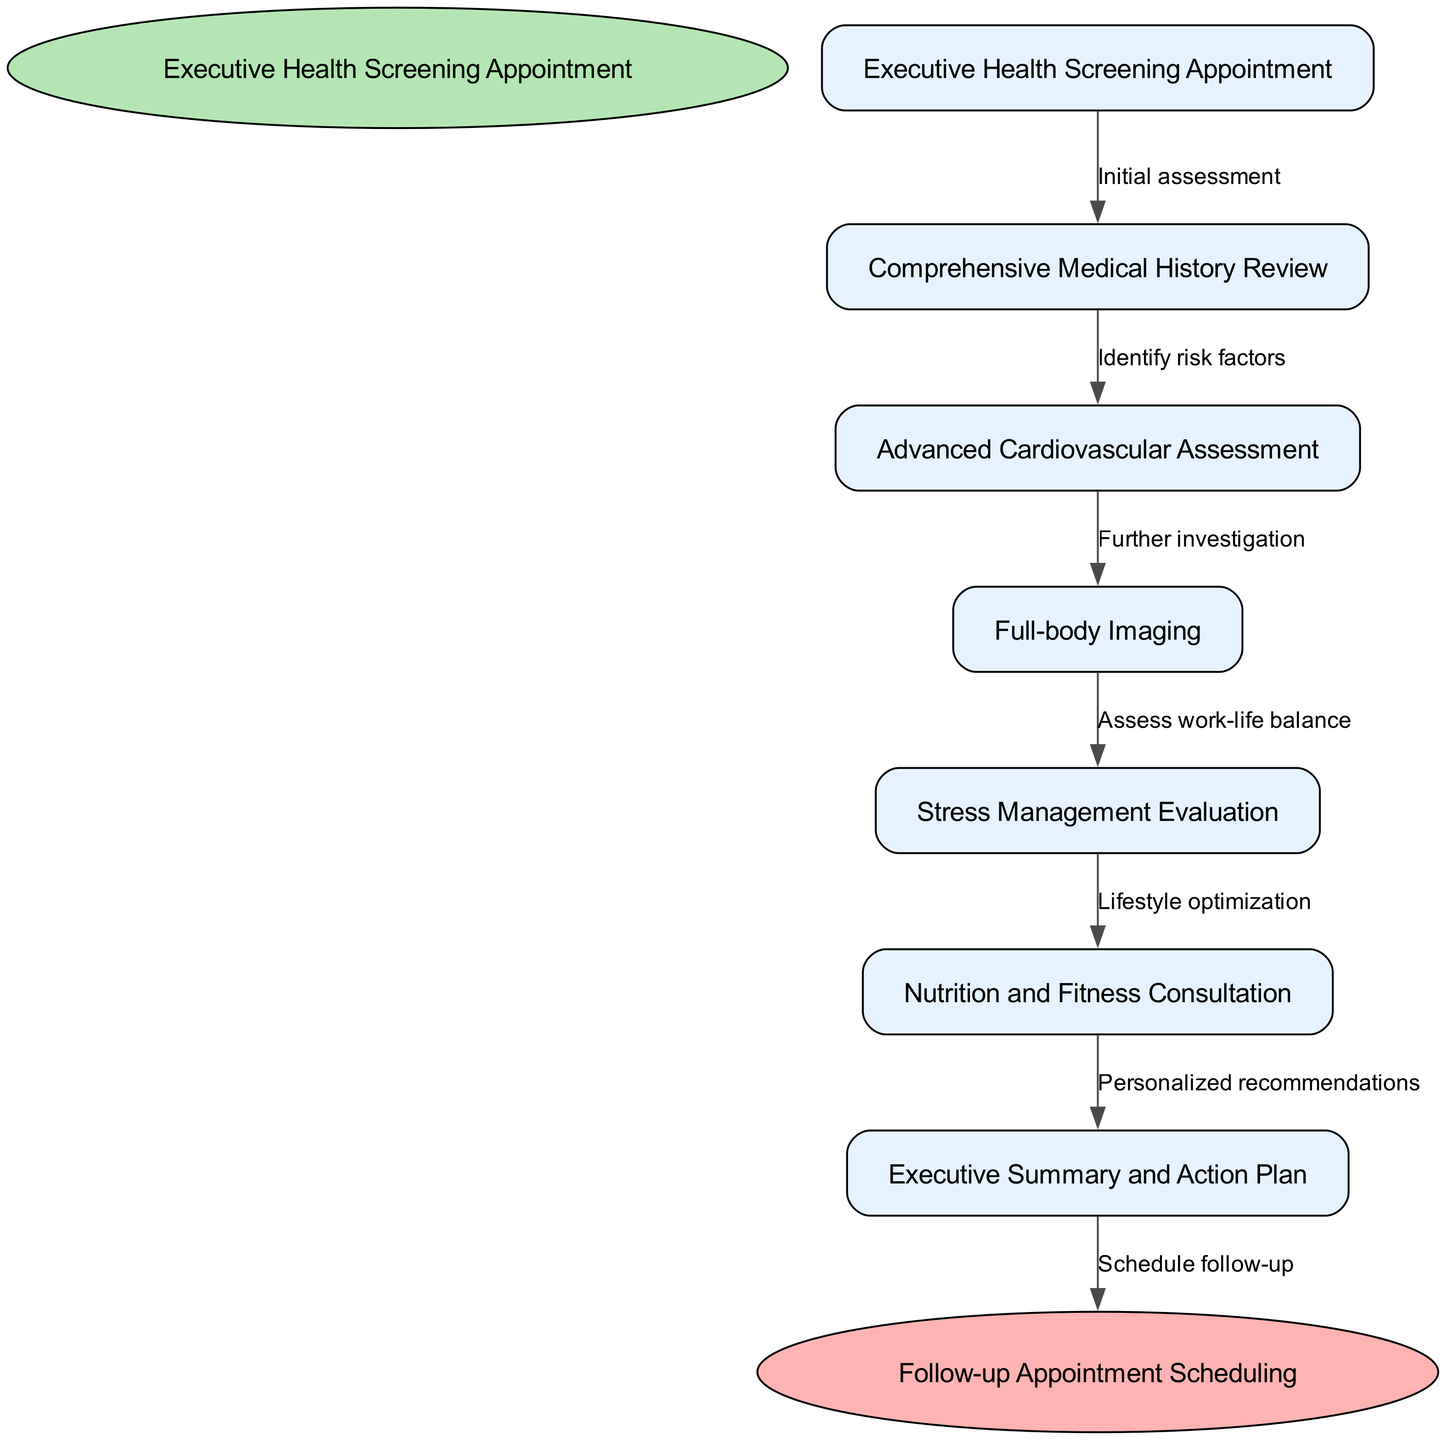What is the starting point of the clinical pathway? The diagram begins with the node labeled "Executive Health Screening Appointment," which is the first step in the clinical pathway.
Answer: Executive Health Screening Appointment How many nodes are present in the clinical pathway? There are a total of 6 nodes included in the clinical pathway, which account for both the stages of evaluation and the start and end points.
Answer: 6 What is the final step before scheduling a follow-up appointment? The last step before scheduling follow-up is "Nutrition and Fitness Consultation," which leads to personalized recommendations.
Answer: Nutrition and Fitness Consultation What is the relationship between the "Comprehensive Medical History Review" and "Advanced Cardiovascular Assessment"? The edge connecting these two nodes is labeled "Identify risk factors," indicating that the medical history review identifies factors that may lead to cardiovascular assessment.
Answer: Identify risk factors How does "Stress Management Evaluation" connect to the next step in the pathway? "Stress Management Evaluation" connects to "Nutrition and Fitness Consultation" through the label "Lifestyle optimization," showing that the evaluation impacts lifestyle choices.
Answer: Lifestyle optimization What type of assessment follows the "Advanced Cardiovascular Assessment"? Following the "Advanced Cardiovascular Assessment," the next assessment is "Full-body Imaging," indicating a further investigation step.
Answer: Full-body Imaging Which node assesses the work-life balance of the executive? The node responsible for assessing work-life balance is "Stress Management Evaluation," aimed at understanding the executive's overall stress factors.
Answer: Stress Management Evaluation What edge label describes the purpose of the node transitioning from "Full-body Imaging" to "Stress Management Evaluation"? The edge label for that transition is "Assess work-life balance," indicating that full-body imaging information is used to evaluate stress levels.
Answer: Assess work-life balance 